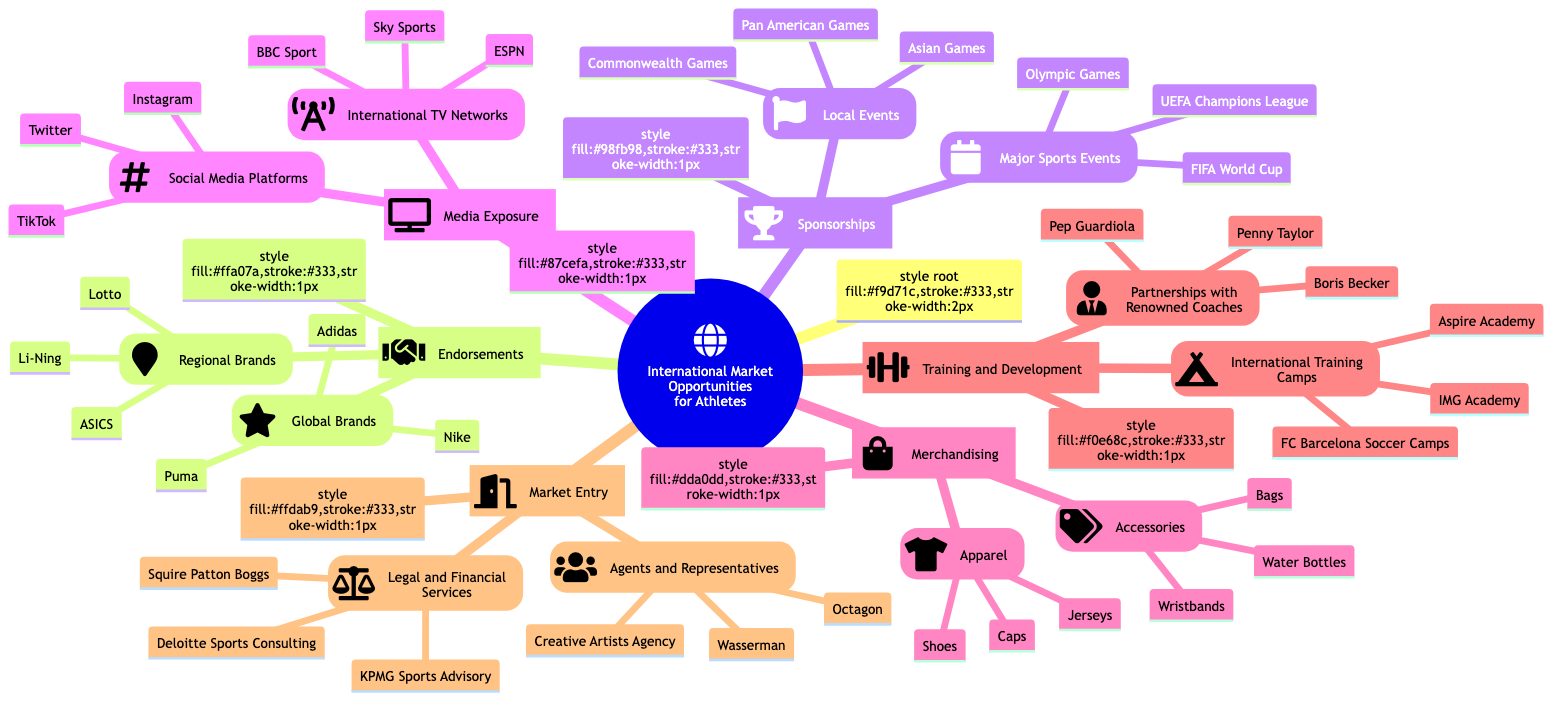What are some global brands mentioned in endorsements? The node under Endorsements lists Global Brands, which includes Nike, Adidas, and Puma.
Answer: Nike, Adidas, Puma How many major sports events are listed under sponsorships? The Major Sports Events node under Sponsorships contains three items: Olympic Games, FIFA World Cup, and UEFA Champions League. Thus, the total is 3.
Answer: 3 What type of services do agents and representatives provide? The Market Entry section includes Agents and Representatives, which typically negotiate contracts and partnerships for athletes, enabling them to enter various markets.
Answer: Negotiation Which social media platforms are highlighted for media exposure? The Media Exposure section includes Social Media Platforms, specifically Instagram, Twitter, and TikTok, as key platforms for athlete engagement.
Answer: Instagram, Twitter, TikTok Which training camp is located in Qatar? Under the Training and Development section, the International Training Camps node lists Aspire Academy (Qatar) as the camp located in Qatar.
Answer: Aspire Academy What is the primary focus of KPMG in the market entry category? The Legal and Financial Services node under Market Entry mentions KPMG Sports Advisory, indicating its focus on providing financial advisory services for athletes.
Answer: Financial Advisory How many items are listed under merchandising apparel? The Merchandising section specifies Apparel, which includes three items: Jerseys, Shoes, and Caps. Therefore, there are 3 items.
Answer: 3 Which athlete partnership is associated with football coaching? Within the Partnerships with Renowned Coaches node, Pep Guardiola is associated with football coaching, indicating his role as a key figure for development in that sport.
Answer: Pep Guardiola How are local events categorized under sponsorships? The Sponsorships section includes Local Events, specifically listing Asian Games, Pan American Games, and Commonwealth Games, all categorized as local sporting events for sponsorships.
Answer: Local Events 